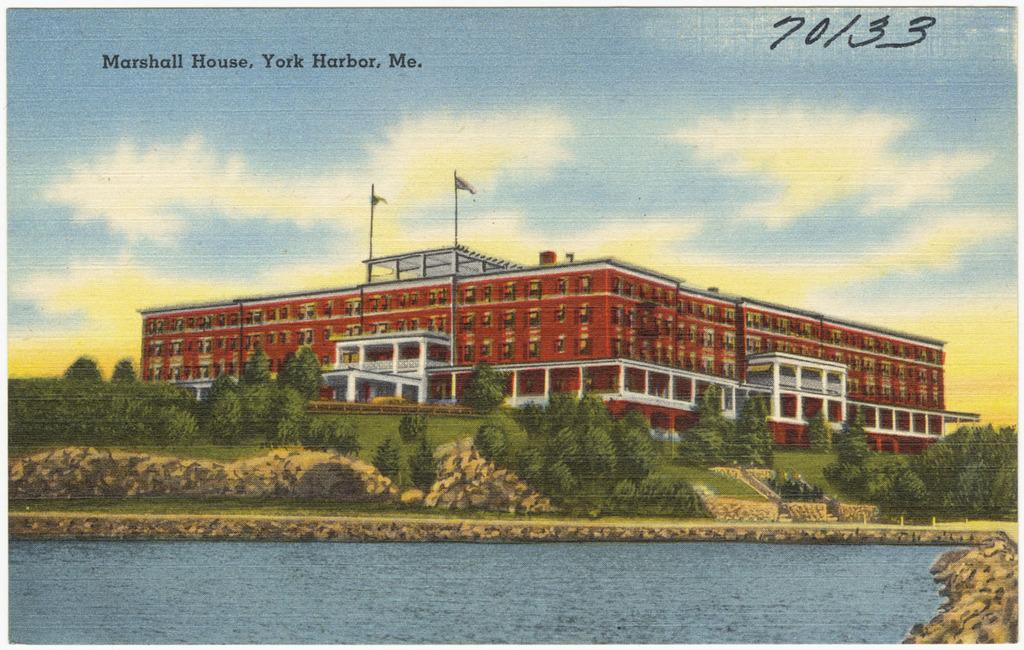<image>
Summarize the visual content of the image. a poster of a building that says 'marshall house' at the top left 